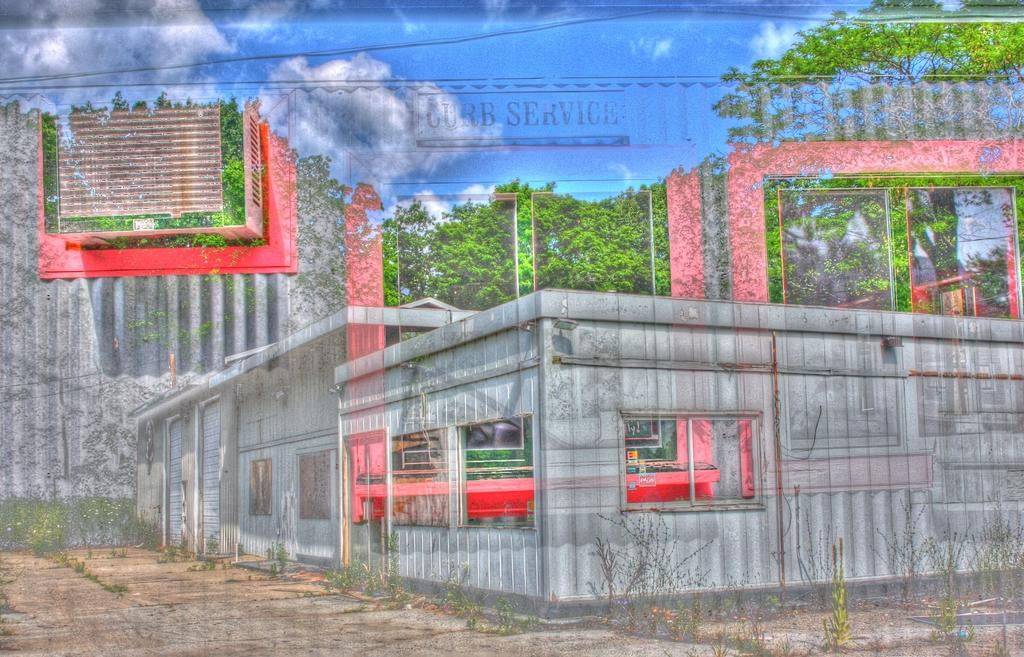What type of structures can be seen in the image? There are buildings in the image. What other natural elements are present in the image? There are trees in the image. What can be seen in the sky in the image? There are clouds in the sky in the image. How many chairs are placed on the ornament in the image? There are no chairs or ornaments present in the image; it features buildings, trees, and clouds. 